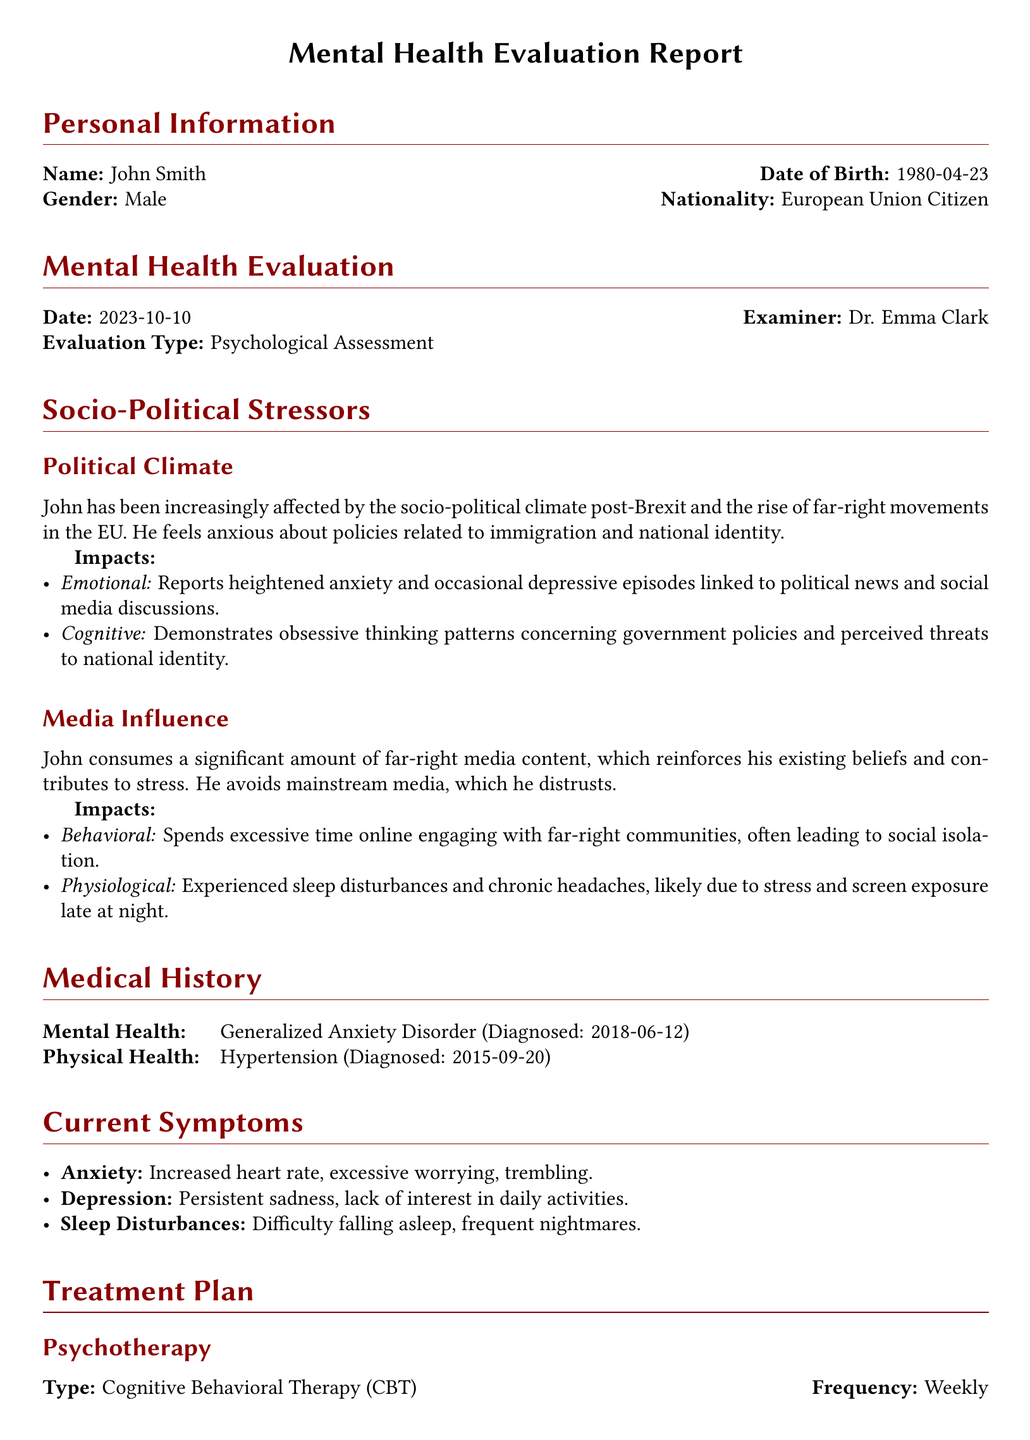What is the patient's name? The patient's name is listed under Personal Information section.
Answer: John Smith What is the date of the mental health evaluation? The date can be found in the Mental Health Evaluation section.
Answer: 2023-10-10 What is the diagnosed mental health condition? The condition is mentioned in the Medical History section.
Answer: Generalized Anxiety Disorder What is the medication prescribed? The medication name is listed in the Medication section.
Answer: Sertraline How often is the psychotherapy scheduled? The frequency of the psychotherapy can be found in the Treatment Plan section.
Answer: Weekly What are the impacts of political climate on John? John’s impacts are detailed in the Socio-Political Stressors section.
Answer: Heightened anxiety and occasional depressive episodes What is the next appointment date? The next appointment date is provided in the Follow-Up section.
Answer: 2023-11-10 What type of therapy is being employed? The therapy type is specified in the Treatment Plan section.
Answer: Cognitive Behavioral Therapy (CBT) What symptoms indicate sleep disturbances? The symptoms for sleep disturbances are listed in Current Symptoms section.
Answer: Difficulty falling asleep, frequent nightmares 